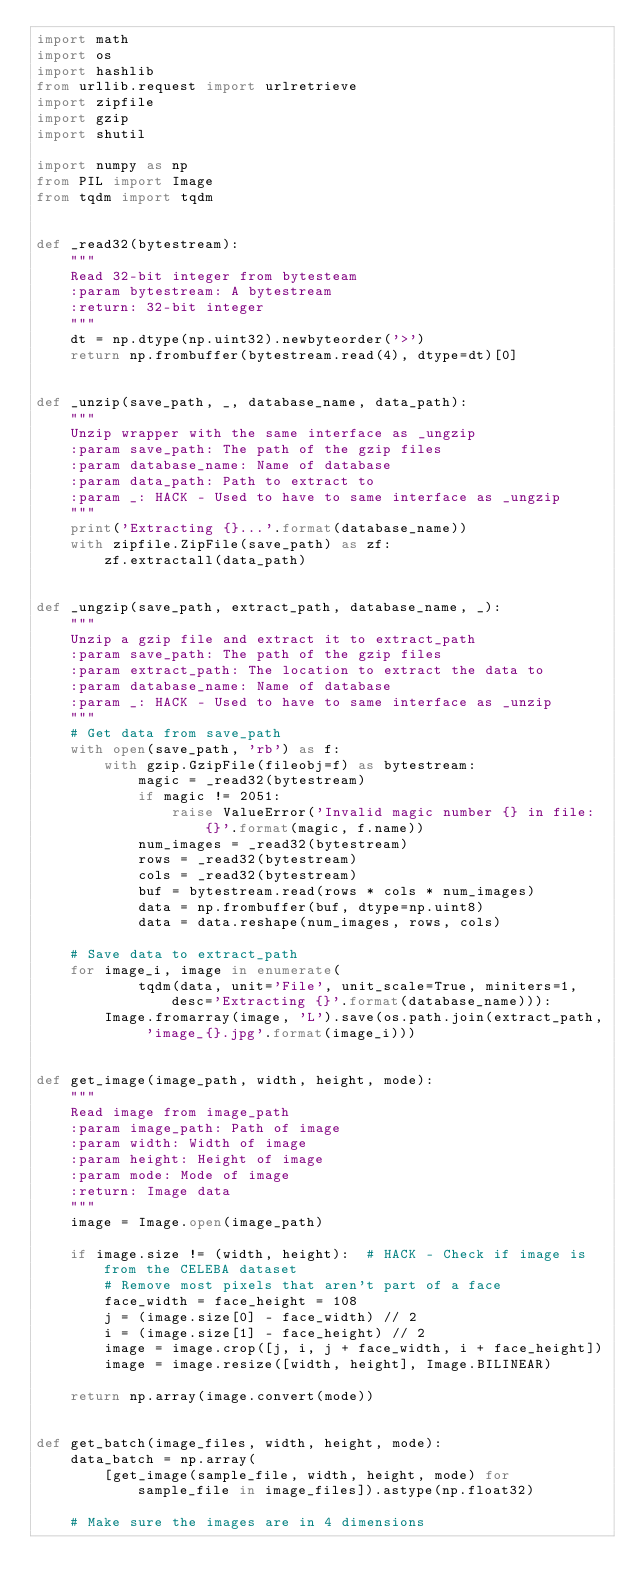Convert code to text. <code><loc_0><loc_0><loc_500><loc_500><_Python_>import math
import os
import hashlib
from urllib.request import urlretrieve
import zipfile
import gzip
import shutil

import numpy as np
from PIL import Image
from tqdm import tqdm


def _read32(bytestream):
    """
    Read 32-bit integer from bytesteam
    :param bytestream: A bytestream
    :return: 32-bit integer
    """
    dt = np.dtype(np.uint32).newbyteorder('>')
    return np.frombuffer(bytestream.read(4), dtype=dt)[0]


def _unzip(save_path, _, database_name, data_path):
    """
    Unzip wrapper with the same interface as _ungzip
    :param save_path: The path of the gzip files
    :param database_name: Name of database
    :param data_path: Path to extract to
    :param _: HACK - Used to have to same interface as _ungzip
    """
    print('Extracting {}...'.format(database_name))
    with zipfile.ZipFile(save_path) as zf:
        zf.extractall(data_path)


def _ungzip(save_path, extract_path, database_name, _):
    """
    Unzip a gzip file and extract it to extract_path
    :param save_path: The path of the gzip files
    :param extract_path: The location to extract the data to
    :param database_name: Name of database
    :param _: HACK - Used to have to same interface as _unzip
    """
    # Get data from save_path
    with open(save_path, 'rb') as f:
        with gzip.GzipFile(fileobj=f) as bytestream:
            magic = _read32(bytestream)
            if magic != 2051:
                raise ValueError('Invalid magic number {} in file: {}'.format(magic, f.name))
            num_images = _read32(bytestream)
            rows = _read32(bytestream)
            cols = _read32(bytestream)
            buf = bytestream.read(rows * cols * num_images)
            data = np.frombuffer(buf, dtype=np.uint8)
            data = data.reshape(num_images, rows, cols)

    # Save data to extract_path
    for image_i, image in enumerate(
            tqdm(data, unit='File', unit_scale=True, miniters=1, desc='Extracting {}'.format(database_name))):
        Image.fromarray(image, 'L').save(os.path.join(extract_path, 'image_{}.jpg'.format(image_i)))


def get_image(image_path, width, height, mode):
    """
    Read image from image_path
    :param image_path: Path of image
    :param width: Width of image
    :param height: Height of image
    :param mode: Mode of image
    :return: Image data
    """
    image = Image.open(image_path)

    if image.size != (width, height):  # HACK - Check if image is from the CELEBA dataset
        # Remove most pixels that aren't part of a face
        face_width = face_height = 108
        j = (image.size[0] - face_width) // 2
        i = (image.size[1] - face_height) // 2
        image = image.crop([j, i, j + face_width, i + face_height])
        image = image.resize([width, height], Image.BILINEAR)

    return np.array(image.convert(mode))


def get_batch(image_files, width, height, mode):
    data_batch = np.array(
        [get_image(sample_file, width, height, mode) for sample_file in image_files]).astype(np.float32)

    # Make sure the images are in 4 dimensions</code> 